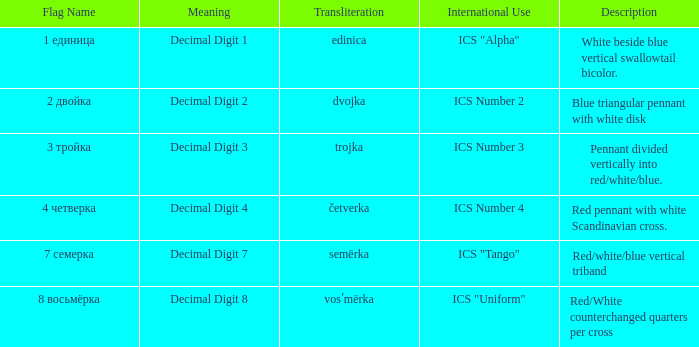How many different descriptions are there for the flag that means decimal digit 2? 1.0. 